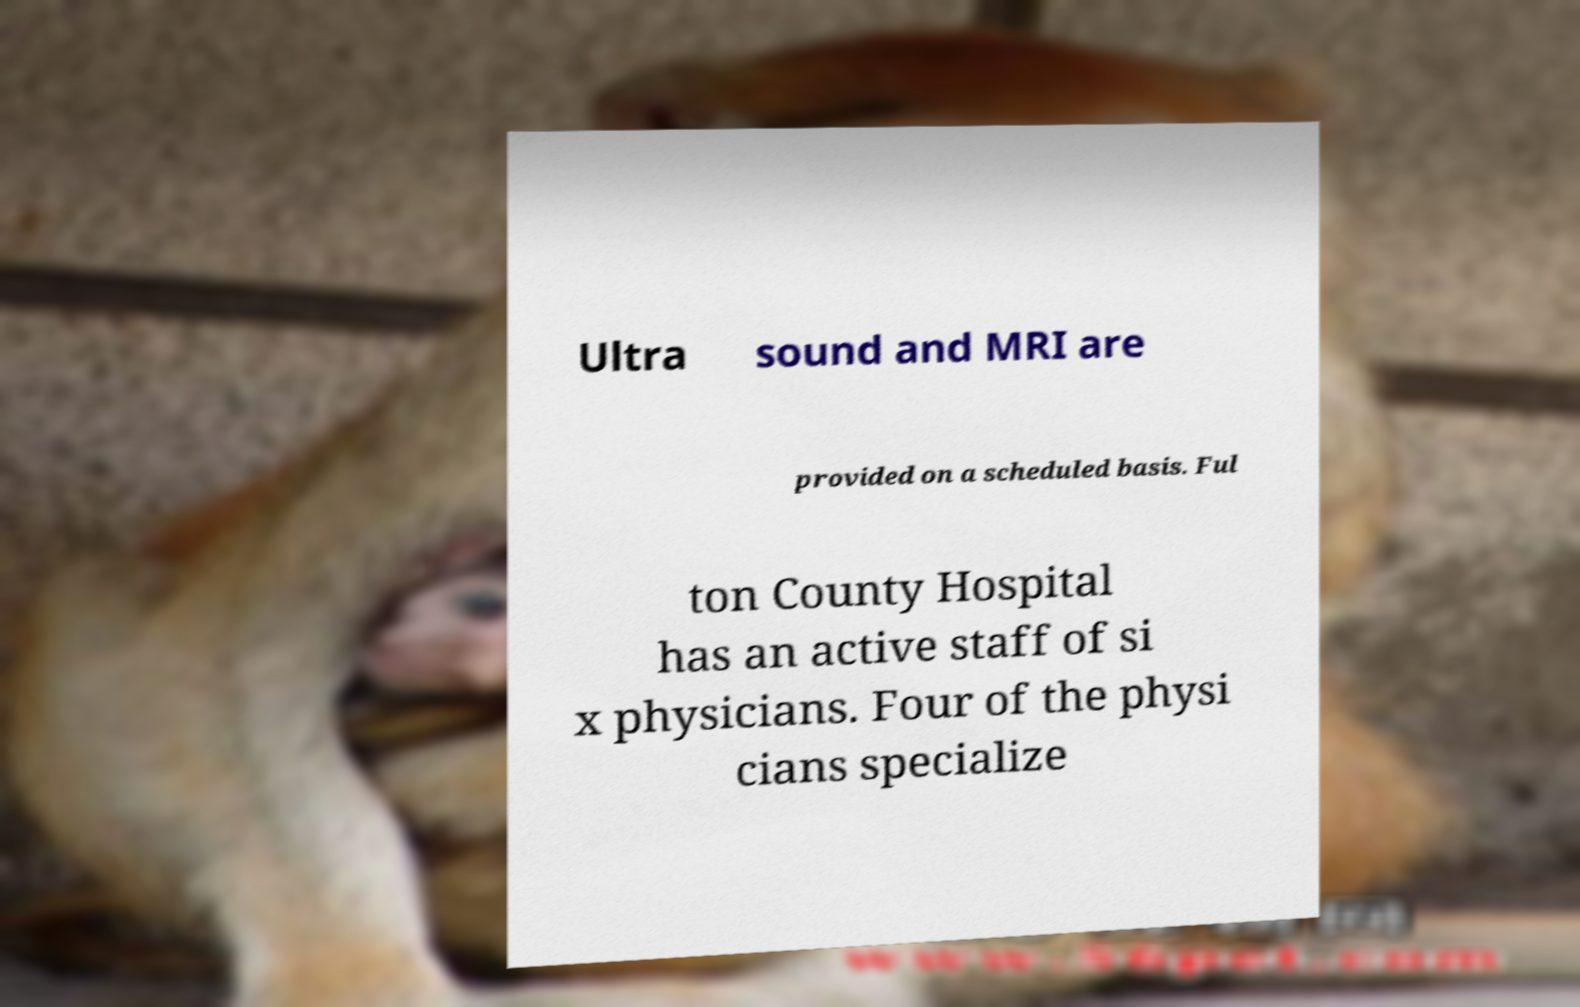For documentation purposes, I need the text within this image transcribed. Could you provide that? Ultra sound and MRI are provided on a scheduled basis. Ful ton County Hospital has an active staff of si x physicians. Four of the physi cians specialize 